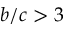<formula> <loc_0><loc_0><loc_500><loc_500>b / c > 3</formula> 